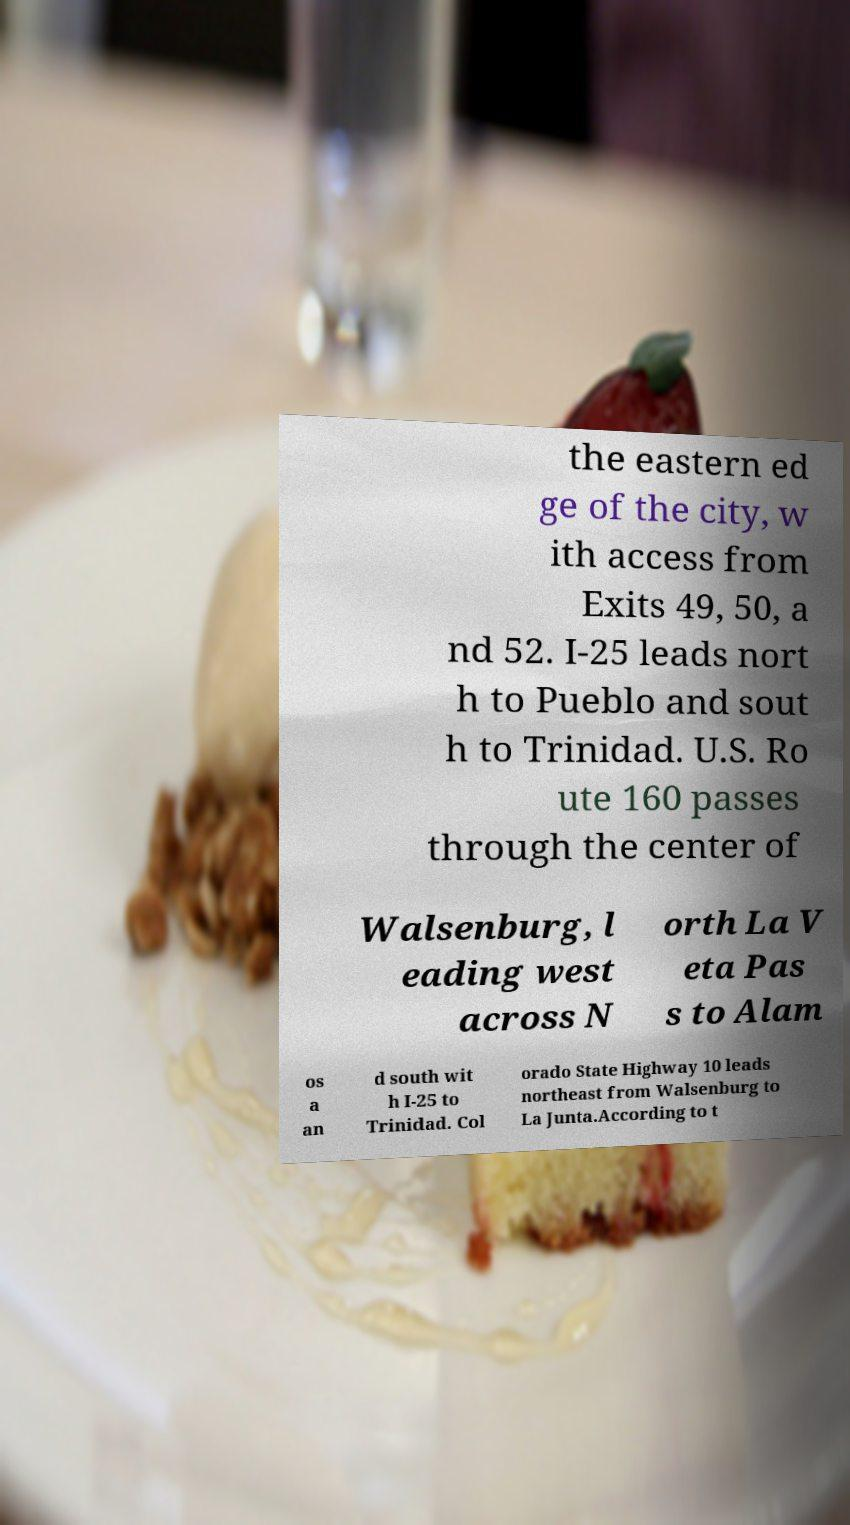Please identify and transcribe the text found in this image. the eastern ed ge of the city, w ith access from Exits 49, 50, a nd 52. I-25 leads nort h to Pueblo and sout h to Trinidad. U.S. Ro ute 160 passes through the center of Walsenburg, l eading west across N orth La V eta Pas s to Alam os a an d south wit h I-25 to Trinidad. Col orado State Highway 10 leads northeast from Walsenburg to La Junta.According to t 